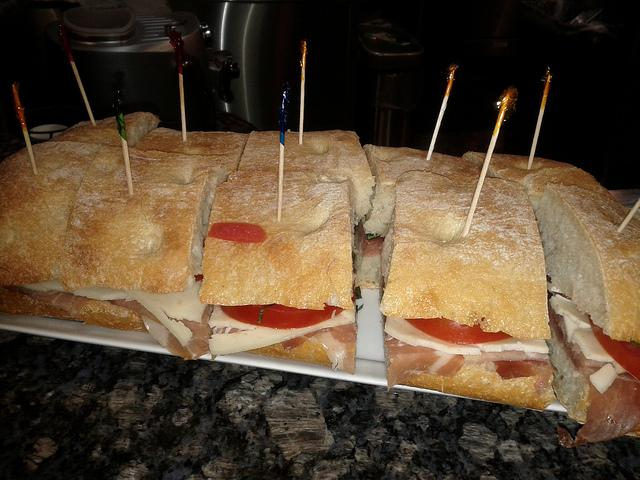What is being used to keep the sandwiches from falling apart? toothpicks 